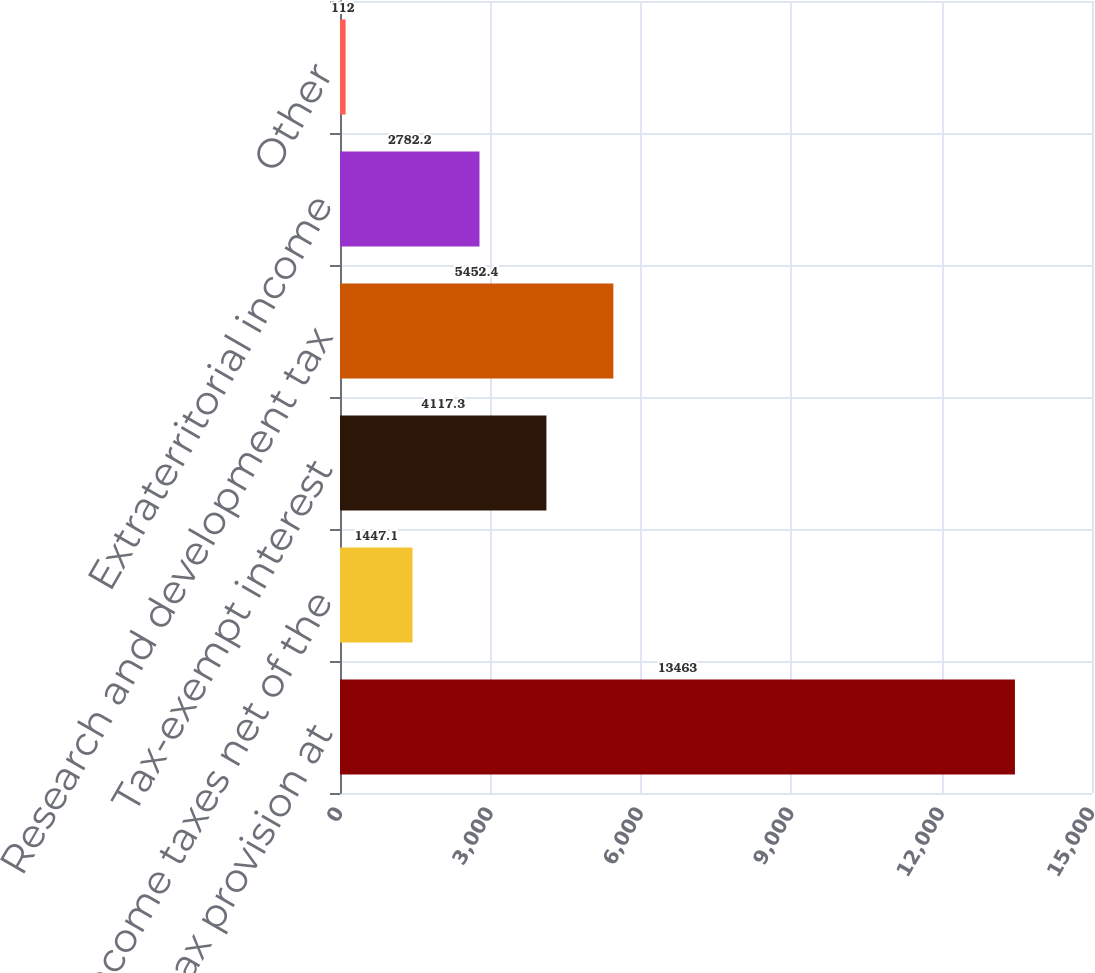<chart> <loc_0><loc_0><loc_500><loc_500><bar_chart><fcel>Income tax provision at<fcel>State income taxes net of the<fcel>Tax-exempt interest<fcel>Research and development tax<fcel>Extraterritorial income<fcel>Other<nl><fcel>13463<fcel>1447.1<fcel>4117.3<fcel>5452.4<fcel>2782.2<fcel>112<nl></chart> 